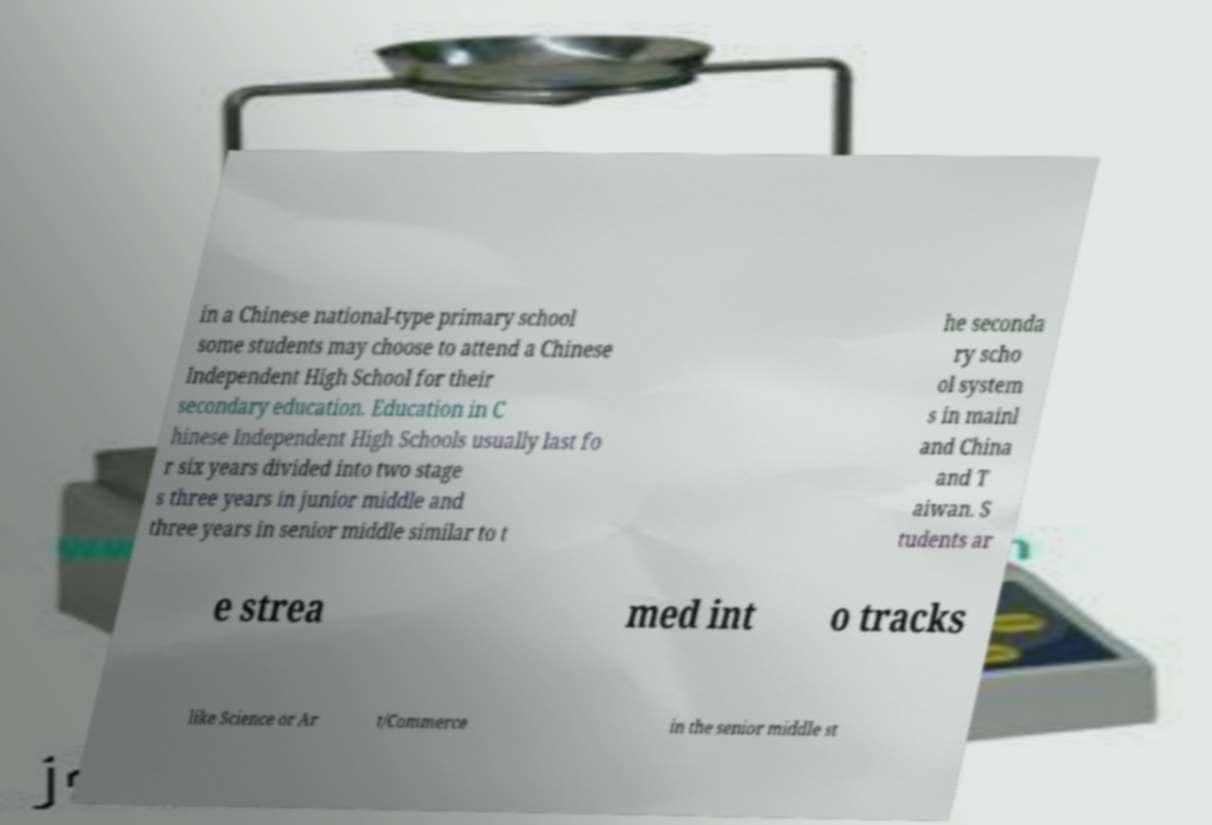Can you read and provide the text displayed in the image?This photo seems to have some interesting text. Can you extract and type it out for me? in a Chinese national-type primary school some students may choose to attend a Chinese Independent High School for their secondary education. Education in C hinese Independent High Schools usually last fo r six years divided into two stage s three years in junior middle and three years in senior middle similar to t he seconda ry scho ol system s in mainl and China and T aiwan. S tudents ar e strea med int o tracks like Science or Ar t/Commerce in the senior middle st 